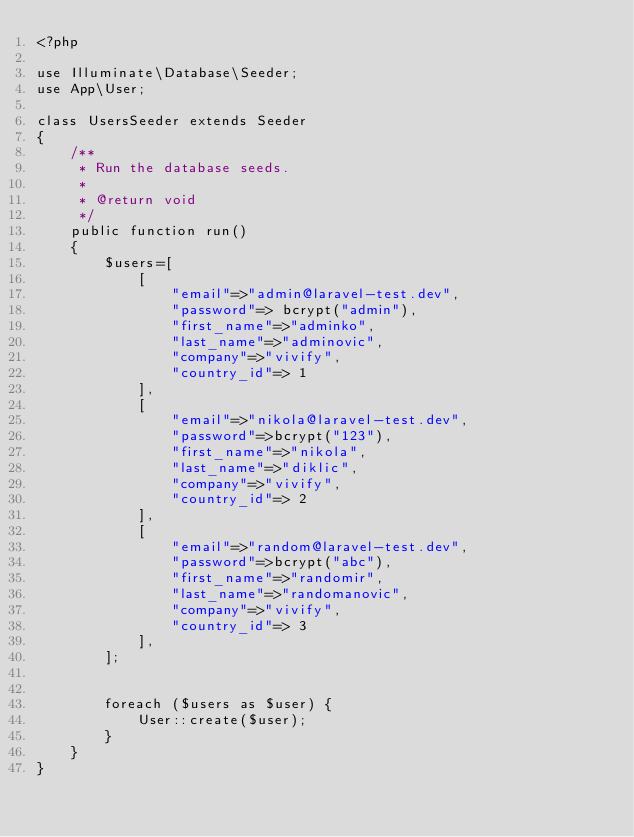Convert code to text. <code><loc_0><loc_0><loc_500><loc_500><_PHP_><?php

use Illuminate\Database\Seeder;
use App\User;

class UsersSeeder extends Seeder
{
    /**
     * Run the database seeds.
     *
     * @return void
     */
    public function run()
    {
        $users=[
    	    [
    	    	"email"=>"admin@laravel-test.dev",
    	    	"password"=> bcrypt("admin"),
    	    	"first_name"=>"adminko",
    	    	"last_name"=>"adminovic",
    	    	"company"=>"vivify",
    	    	"country_id"=> 1
			],
			[
    	    	"email"=>"nikola@laravel-test.dev",
    	    	"password"=>bcrypt("123"),
    	    	"first_name"=>"nikola",
    	    	"last_name"=>"diklic",
    	    	"company"=>"vivify",
    	    	"country_id"=> 2
			],
			[
    	    	"email"=>"random@laravel-test.dev",
    	    	"password"=>bcrypt("abc"),
    	    	"first_name"=>"randomir",
    	    	"last_name"=>"randomanovic",
    	    	"company"=>"vivify",
    	    	"country_id"=> 3
			],
    	];


        foreach ($users as $user) {
        	User::create($user);
        }
    }
}
</code> 